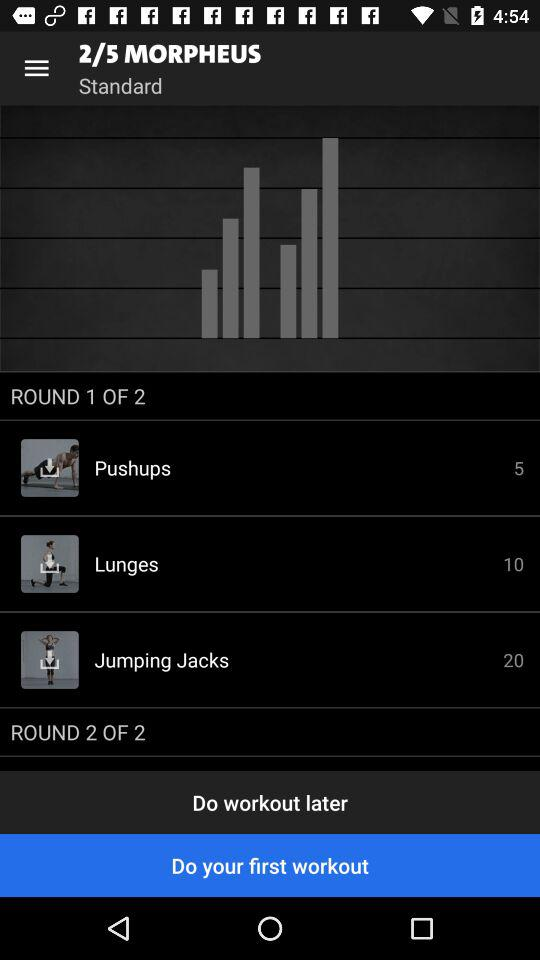What is the number of pushups? The number of pushups is 5. 